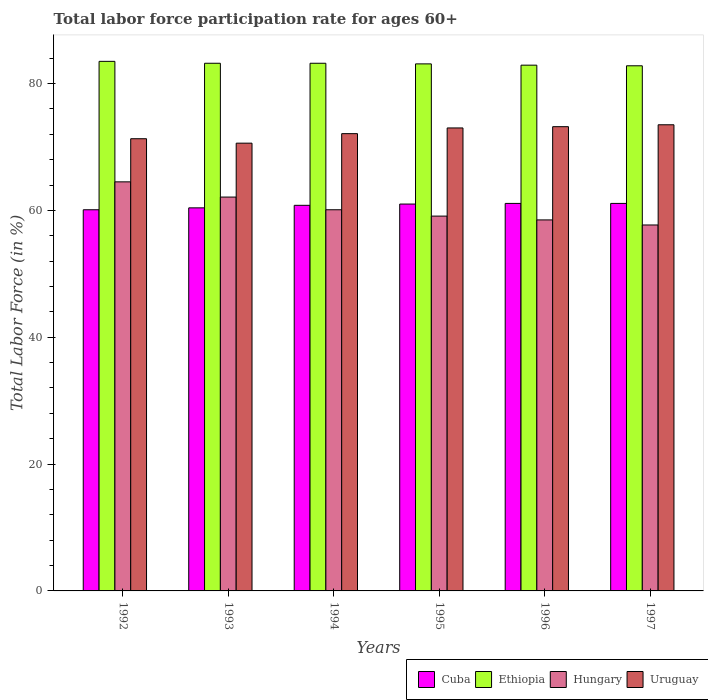How many different coloured bars are there?
Offer a very short reply. 4. How many groups of bars are there?
Your response must be concise. 6. Are the number of bars on each tick of the X-axis equal?
Provide a short and direct response. Yes. How many bars are there on the 4th tick from the left?
Offer a very short reply. 4. How many bars are there on the 5th tick from the right?
Keep it short and to the point. 4. What is the label of the 1st group of bars from the left?
Your answer should be very brief. 1992. In how many cases, is the number of bars for a given year not equal to the number of legend labels?
Your answer should be compact. 0. What is the labor force participation rate in Hungary in 1992?
Provide a succinct answer. 64.5. Across all years, what is the maximum labor force participation rate in Ethiopia?
Keep it short and to the point. 83.5. Across all years, what is the minimum labor force participation rate in Cuba?
Offer a very short reply. 60.1. In which year was the labor force participation rate in Uruguay maximum?
Offer a very short reply. 1997. In which year was the labor force participation rate in Cuba minimum?
Your response must be concise. 1992. What is the total labor force participation rate in Hungary in the graph?
Offer a terse response. 362. What is the difference between the labor force participation rate in Uruguay in 1996 and that in 1997?
Your answer should be very brief. -0.3. What is the difference between the labor force participation rate in Ethiopia in 1997 and the labor force participation rate in Cuba in 1994?
Provide a succinct answer. 22. What is the average labor force participation rate in Ethiopia per year?
Give a very brief answer. 83.12. In the year 1994, what is the difference between the labor force participation rate in Uruguay and labor force participation rate in Ethiopia?
Give a very brief answer. -11.1. What is the ratio of the labor force participation rate in Ethiopia in 1992 to that in 1995?
Your answer should be compact. 1. Is the labor force participation rate in Ethiopia in 1994 less than that in 1997?
Provide a succinct answer. No. Is the difference between the labor force participation rate in Uruguay in 1992 and 1993 greater than the difference between the labor force participation rate in Ethiopia in 1992 and 1993?
Offer a very short reply. Yes. What is the difference between the highest and the lowest labor force participation rate in Cuba?
Offer a very short reply. 1. In how many years, is the labor force participation rate in Hungary greater than the average labor force participation rate in Hungary taken over all years?
Offer a very short reply. 2. Is the sum of the labor force participation rate in Ethiopia in 1994 and 1997 greater than the maximum labor force participation rate in Hungary across all years?
Keep it short and to the point. Yes. Is it the case that in every year, the sum of the labor force participation rate in Cuba and labor force participation rate in Hungary is greater than the sum of labor force participation rate in Uruguay and labor force participation rate in Ethiopia?
Give a very brief answer. No. What does the 1st bar from the left in 1993 represents?
Ensure brevity in your answer.  Cuba. What does the 2nd bar from the right in 1995 represents?
Keep it short and to the point. Hungary. Is it the case that in every year, the sum of the labor force participation rate in Hungary and labor force participation rate in Ethiopia is greater than the labor force participation rate in Uruguay?
Offer a very short reply. Yes. How many bars are there?
Provide a succinct answer. 24. Are all the bars in the graph horizontal?
Provide a succinct answer. No. Does the graph contain any zero values?
Provide a short and direct response. No. Does the graph contain grids?
Make the answer very short. No. What is the title of the graph?
Your answer should be compact. Total labor force participation rate for ages 60+. What is the label or title of the X-axis?
Your answer should be compact. Years. What is the label or title of the Y-axis?
Give a very brief answer. Total Labor Force (in %). What is the Total Labor Force (in %) of Cuba in 1992?
Give a very brief answer. 60.1. What is the Total Labor Force (in %) of Ethiopia in 1992?
Offer a very short reply. 83.5. What is the Total Labor Force (in %) of Hungary in 1992?
Ensure brevity in your answer.  64.5. What is the Total Labor Force (in %) of Uruguay in 1992?
Offer a very short reply. 71.3. What is the Total Labor Force (in %) in Cuba in 1993?
Your answer should be compact. 60.4. What is the Total Labor Force (in %) in Ethiopia in 1993?
Your answer should be compact. 83.2. What is the Total Labor Force (in %) of Hungary in 1993?
Your answer should be very brief. 62.1. What is the Total Labor Force (in %) in Uruguay in 1993?
Your response must be concise. 70.6. What is the Total Labor Force (in %) in Cuba in 1994?
Your answer should be compact. 60.8. What is the Total Labor Force (in %) of Ethiopia in 1994?
Keep it short and to the point. 83.2. What is the Total Labor Force (in %) in Hungary in 1994?
Keep it short and to the point. 60.1. What is the Total Labor Force (in %) in Uruguay in 1994?
Make the answer very short. 72.1. What is the Total Labor Force (in %) in Ethiopia in 1995?
Provide a short and direct response. 83.1. What is the Total Labor Force (in %) of Hungary in 1995?
Your answer should be compact. 59.1. What is the Total Labor Force (in %) of Cuba in 1996?
Provide a short and direct response. 61.1. What is the Total Labor Force (in %) of Ethiopia in 1996?
Offer a terse response. 82.9. What is the Total Labor Force (in %) of Hungary in 1996?
Provide a succinct answer. 58.5. What is the Total Labor Force (in %) of Uruguay in 1996?
Offer a very short reply. 73.2. What is the Total Labor Force (in %) of Cuba in 1997?
Give a very brief answer. 61.1. What is the Total Labor Force (in %) of Ethiopia in 1997?
Give a very brief answer. 82.8. What is the Total Labor Force (in %) of Hungary in 1997?
Offer a very short reply. 57.7. What is the Total Labor Force (in %) in Uruguay in 1997?
Your answer should be compact. 73.5. Across all years, what is the maximum Total Labor Force (in %) of Cuba?
Your answer should be compact. 61.1. Across all years, what is the maximum Total Labor Force (in %) in Ethiopia?
Your response must be concise. 83.5. Across all years, what is the maximum Total Labor Force (in %) in Hungary?
Make the answer very short. 64.5. Across all years, what is the maximum Total Labor Force (in %) in Uruguay?
Provide a short and direct response. 73.5. Across all years, what is the minimum Total Labor Force (in %) in Cuba?
Provide a succinct answer. 60.1. Across all years, what is the minimum Total Labor Force (in %) of Ethiopia?
Offer a terse response. 82.8. Across all years, what is the minimum Total Labor Force (in %) in Hungary?
Provide a succinct answer. 57.7. Across all years, what is the minimum Total Labor Force (in %) in Uruguay?
Offer a very short reply. 70.6. What is the total Total Labor Force (in %) in Cuba in the graph?
Ensure brevity in your answer.  364.5. What is the total Total Labor Force (in %) of Ethiopia in the graph?
Make the answer very short. 498.7. What is the total Total Labor Force (in %) of Hungary in the graph?
Give a very brief answer. 362. What is the total Total Labor Force (in %) in Uruguay in the graph?
Offer a very short reply. 433.7. What is the difference between the Total Labor Force (in %) in Cuba in 1992 and that in 1994?
Give a very brief answer. -0.7. What is the difference between the Total Labor Force (in %) of Hungary in 1992 and that in 1994?
Give a very brief answer. 4.4. What is the difference between the Total Labor Force (in %) in Uruguay in 1992 and that in 1994?
Your answer should be compact. -0.8. What is the difference between the Total Labor Force (in %) in Hungary in 1992 and that in 1995?
Ensure brevity in your answer.  5.4. What is the difference between the Total Labor Force (in %) of Ethiopia in 1992 and that in 1996?
Give a very brief answer. 0.6. What is the difference between the Total Labor Force (in %) of Hungary in 1992 and that in 1997?
Provide a short and direct response. 6.8. What is the difference between the Total Labor Force (in %) in Uruguay in 1992 and that in 1997?
Give a very brief answer. -2.2. What is the difference between the Total Labor Force (in %) in Cuba in 1993 and that in 1994?
Keep it short and to the point. -0.4. What is the difference between the Total Labor Force (in %) of Uruguay in 1993 and that in 1994?
Your answer should be very brief. -1.5. What is the difference between the Total Labor Force (in %) of Cuba in 1993 and that in 1996?
Give a very brief answer. -0.7. What is the difference between the Total Labor Force (in %) of Ethiopia in 1993 and that in 1996?
Ensure brevity in your answer.  0.3. What is the difference between the Total Labor Force (in %) of Ethiopia in 1993 and that in 1997?
Give a very brief answer. 0.4. What is the difference between the Total Labor Force (in %) of Hungary in 1993 and that in 1997?
Offer a terse response. 4.4. What is the difference between the Total Labor Force (in %) in Uruguay in 1993 and that in 1997?
Give a very brief answer. -2.9. What is the difference between the Total Labor Force (in %) in Hungary in 1994 and that in 1995?
Make the answer very short. 1. What is the difference between the Total Labor Force (in %) of Uruguay in 1994 and that in 1995?
Keep it short and to the point. -0.9. What is the difference between the Total Labor Force (in %) of Cuba in 1994 and that in 1996?
Your response must be concise. -0.3. What is the difference between the Total Labor Force (in %) in Uruguay in 1994 and that in 1996?
Keep it short and to the point. -1.1. What is the difference between the Total Labor Force (in %) of Cuba in 1994 and that in 1997?
Make the answer very short. -0.3. What is the difference between the Total Labor Force (in %) of Ethiopia in 1994 and that in 1997?
Provide a succinct answer. 0.4. What is the difference between the Total Labor Force (in %) in Uruguay in 1994 and that in 1997?
Offer a very short reply. -1.4. What is the difference between the Total Labor Force (in %) in Cuba in 1995 and that in 1996?
Offer a very short reply. -0.1. What is the difference between the Total Labor Force (in %) of Hungary in 1995 and that in 1996?
Give a very brief answer. 0.6. What is the difference between the Total Labor Force (in %) of Cuba in 1995 and that in 1997?
Your answer should be compact. -0.1. What is the difference between the Total Labor Force (in %) of Ethiopia in 1995 and that in 1997?
Offer a very short reply. 0.3. What is the difference between the Total Labor Force (in %) in Uruguay in 1995 and that in 1997?
Offer a very short reply. -0.5. What is the difference between the Total Labor Force (in %) in Ethiopia in 1996 and that in 1997?
Offer a very short reply. 0.1. What is the difference between the Total Labor Force (in %) in Hungary in 1996 and that in 1997?
Offer a terse response. 0.8. What is the difference between the Total Labor Force (in %) in Uruguay in 1996 and that in 1997?
Offer a very short reply. -0.3. What is the difference between the Total Labor Force (in %) of Cuba in 1992 and the Total Labor Force (in %) of Ethiopia in 1993?
Offer a terse response. -23.1. What is the difference between the Total Labor Force (in %) of Cuba in 1992 and the Total Labor Force (in %) of Hungary in 1993?
Offer a very short reply. -2. What is the difference between the Total Labor Force (in %) of Ethiopia in 1992 and the Total Labor Force (in %) of Hungary in 1993?
Provide a short and direct response. 21.4. What is the difference between the Total Labor Force (in %) of Hungary in 1992 and the Total Labor Force (in %) of Uruguay in 1993?
Give a very brief answer. -6.1. What is the difference between the Total Labor Force (in %) in Cuba in 1992 and the Total Labor Force (in %) in Ethiopia in 1994?
Make the answer very short. -23.1. What is the difference between the Total Labor Force (in %) in Ethiopia in 1992 and the Total Labor Force (in %) in Hungary in 1994?
Offer a terse response. 23.4. What is the difference between the Total Labor Force (in %) of Ethiopia in 1992 and the Total Labor Force (in %) of Uruguay in 1994?
Provide a short and direct response. 11.4. What is the difference between the Total Labor Force (in %) in Hungary in 1992 and the Total Labor Force (in %) in Uruguay in 1994?
Offer a very short reply. -7.6. What is the difference between the Total Labor Force (in %) in Cuba in 1992 and the Total Labor Force (in %) in Ethiopia in 1995?
Your answer should be very brief. -23. What is the difference between the Total Labor Force (in %) in Cuba in 1992 and the Total Labor Force (in %) in Hungary in 1995?
Offer a very short reply. 1. What is the difference between the Total Labor Force (in %) of Cuba in 1992 and the Total Labor Force (in %) of Uruguay in 1995?
Your response must be concise. -12.9. What is the difference between the Total Labor Force (in %) of Ethiopia in 1992 and the Total Labor Force (in %) of Hungary in 1995?
Keep it short and to the point. 24.4. What is the difference between the Total Labor Force (in %) in Hungary in 1992 and the Total Labor Force (in %) in Uruguay in 1995?
Give a very brief answer. -8.5. What is the difference between the Total Labor Force (in %) in Cuba in 1992 and the Total Labor Force (in %) in Ethiopia in 1996?
Provide a succinct answer. -22.8. What is the difference between the Total Labor Force (in %) of Cuba in 1992 and the Total Labor Force (in %) of Hungary in 1996?
Your answer should be very brief. 1.6. What is the difference between the Total Labor Force (in %) of Cuba in 1992 and the Total Labor Force (in %) of Uruguay in 1996?
Keep it short and to the point. -13.1. What is the difference between the Total Labor Force (in %) in Ethiopia in 1992 and the Total Labor Force (in %) in Hungary in 1996?
Offer a very short reply. 25. What is the difference between the Total Labor Force (in %) of Ethiopia in 1992 and the Total Labor Force (in %) of Uruguay in 1996?
Give a very brief answer. 10.3. What is the difference between the Total Labor Force (in %) in Cuba in 1992 and the Total Labor Force (in %) in Ethiopia in 1997?
Offer a very short reply. -22.7. What is the difference between the Total Labor Force (in %) of Cuba in 1992 and the Total Labor Force (in %) of Hungary in 1997?
Provide a short and direct response. 2.4. What is the difference between the Total Labor Force (in %) of Cuba in 1992 and the Total Labor Force (in %) of Uruguay in 1997?
Offer a very short reply. -13.4. What is the difference between the Total Labor Force (in %) of Ethiopia in 1992 and the Total Labor Force (in %) of Hungary in 1997?
Your answer should be very brief. 25.8. What is the difference between the Total Labor Force (in %) of Ethiopia in 1992 and the Total Labor Force (in %) of Uruguay in 1997?
Ensure brevity in your answer.  10. What is the difference between the Total Labor Force (in %) in Hungary in 1992 and the Total Labor Force (in %) in Uruguay in 1997?
Your answer should be compact. -9. What is the difference between the Total Labor Force (in %) of Cuba in 1993 and the Total Labor Force (in %) of Ethiopia in 1994?
Offer a very short reply. -22.8. What is the difference between the Total Labor Force (in %) of Cuba in 1993 and the Total Labor Force (in %) of Uruguay in 1994?
Your answer should be compact. -11.7. What is the difference between the Total Labor Force (in %) of Ethiopia in 1993 and the Total Labor Force (in %) of Hungary in 1994?
Offer a terse response. 23.1. What is the difference between the Total Labor Force (in %) in Hungary in 1993 and the Total Labor Force (in %) in Uruguay in 1994?
Your response must be concise. -10. What is the difference between the Total Labor Force (in %) in Cuba in 1993 and the Total Labor Force (in %) in Ethiopia in 1995?
Offer a very short reply. -22.7. What is the difference between the Total Labor Force (in %) of Ethiopia in 1993 and the Total Labor Force (in %) of Hungary in 1995?
Your answer should be compact. 24.1. What is the difference between the Total Labor Force (in %) of Hungary in 1993 and the Total Labor Force (in %) of Uruguay in 1995?
Your answer should be very brief. -10.9. What is the difference between the Total Labor Force (in %) in Cuba in 1993 and the Total Labor Force (in %) in Ethiopia in 1996?
Provide a short and direct response. -22.5. What is the difference between the Total Labor Force (in %) of Ethiopia in 1993 and the Total Labor Force (in %) of Hungary in 1996?
Provide a succinct answer. 24.7. What is the difference between the Total Labor Force (in %) in Hungary in 1993 and the Total Labor Force (in %) in Uruguay in 1996?
Offer a terse response. -11.1. What is the difference between the Total Labor Force (in %) of Cuba in 1993 and the Total Labor Force (in %) of Ethiopia in 1997?
Your answer should be compact. -22.4. What is the difference between the Total Labor Force (in %) in Cuba in 1994 and the Total Labor Force (in %) in Ethiopia in 1995?
Your response must be concise. -22.3. What is the difference between the Total Labor Force (in %) in Cuba in 1994 and the Total Labor Force (in %) in Uruguay in 1995?
Give a very brief answer. -12.2. What is the difference between the Total Labor Force (in %) of Ethiopia in 1994 and the Total Labor Force (in %) of Hungary in 1995?
Make the answer very short. 24.1. What is the difference between the Total Labor Force (in %) of Hungary in 1994 and the Total Labor Force (in %) of Uruguay in 1995?
Ensure brevity in your answer.  -12.9. What is the difference between the Total Labor Force (in %) in Cuba in 1994 and the Total Labor Force (in %) in Ethiopia in 1996?
Your answer should be compact. -22.1. What is the difference between the Total Labor Force (in %) in Cuba in 1994 and the Total Labor Force (in %) in Hungary in 1996?
Your response must be concise. 2.3. What is the difference between the Total Labor Force (in %) of Ethiopia in 1994 and the Total Labor Force (in %) of Hungary in 1996?
Make the answer very short. 24.7. What is the difference between the Total Labor Force (in %) of Ethiopia in 1994 and the Total Labor Force (in %) of Uruguay in 1996?
Ensure brevity in your answer.  10. What is the difference between the Total Labor Force (in %) in Hungary in 1994 and the Total Labor Force (in %) in Uruguay in 1996?
Provide a short and direct response. -13.1. What is the difference between the Total Labor Force (in %) of Ethiopia in 1994 and the Total Labor Force (in %) of Hungary in 1997?
Offer a very short reply. 25.5. What is the difference between the Total Labor Force (in %) in Hungary in 1994 and the Total Labor Force (in %) in Uruguay in 1997?
Give a very brief answer. -13.4. What is the difference between the Total Labor Force (in %) of Cuba in 1995 and the Total Labor Force (in %) of Ethiopia in 1996?
Your response must be concise. -21.9. What is the difference between the Total Labor Force (in %) in Cuba in 1995 and the Total Labor Force (in %) in Hungary in 1996?
Your response must be concise. 2.5. What is the difference between the Total Labor Force (in %) in Cuba in 1995 and the Total Labor Force (in %) in Uruguay in 1996?
Make the answer very short. -12.2. What is the difference between the Total Labor Force (in %) of Ethiopia in 1995 and the Total Labor Force (in %) of Hungary in 1996?
Provide a succinct answer. 24.6. What is the difference between the Total Labor Force (in %) of Hungary in 1995 and the Total Labor Force (in %) of Uruguay in 1996?
Offer a very short reply. -14.1. What is the difference between the Total Labor Force (in %) of Cuba in 1995 and the Total Labor Force (in %) of Ethiopia in 1997?
Offer a terse response. -21.8. What is the difference between the Total Labor Force (in %) in Cuba in 1995 and the Total Labor Force (in %) in Uruguay in 1997?
Your answer should be very brief. -12.5. What is the difference between the Total Labor Force (in %) in Ethiopia in 1995 and the Total Labor Force (in %) in Hungary in 1997?
Provide a short and direct response. 25.4. What is the difference between the Total Labor Force (in %) of Hungary in 1995 and the Total Labor Force (in %) of Uruguay in 1997?
Your response must be concise. -14.4. What is the difference between the Total Labor Force (in %) in Cuba in 1996 and the Total Labor Force (in %) in Ethiopia in 1997?
Your answer should be compact. -21.7. What is the difference between the Total Labor Force (in %) in Cuba in 1996 and the Total Labor Force (in %) in Hungary in 1997?
Provide a succinct answer. 3.4. What is the difference between the Total Labor Force (in %) in Ethiopia in 1996 and the Total Labor Force (in %) in Hungary in 1997?
Offer a terse response. 25.2. What is the average Total Labor Force (in %) of Cuba per year?
Your answer should be compact. 60.75. What is the average Total Labor Force (in %) in Ethiopia per year?
Make the answer very short. 83.12. What is the average Total Labor Force (in %) in Hungary per year?
Offer a terse response. 60.33. What is the average Total Labor Force (in %) of Uruguay per year?
Offer a terse response. 72.28. In the year 1992, what is the difference between the Total Labor Force (in %) of Cuba and Total Labor Force (in %) of Ethiopia?
Your response must be concise. -23.4. In the year 1992, what is the difference between the Total Labor Force (in %) of Cuba and Total Labor Force (in %) of Uruguay?
Provide a succinct answer. -11.2. In the year 1992, what is the difference between the Total Labor Force (in %) in Ethiopia and Total Labor Force (in %) in Hungary?
Make the answer very short. 19. In the year 1992, what is the difference between the Total Labor Force (in %) of Hungary and Total Labor Force (in %) of Uruguay?
Make the answer very short. -6.8. In the year 1993, what is the difference between the Total Labor Force (in %) in Cuba and Total Labor Force (in %) in Ethiopia?
Your answer should be very brief. -22.8. In the year 1993, what is the difference between the Total Labor Force (in %) of Cuba and Total Labor Force (in %) of Hungary?
Give a very brief answer. -1.7. In the year 1993, what is the difference between the Total Labor Force (in %) in Cuba and Total Labor Force (in %) in Uruguay?
Provide a succinct answer. -10.2. In the year 1993, what is the difference between the Total Labor Force (in %) of Ethiopia and Total Labor Force (in %) of Hungary?
Your response must be concise. 21.1. In the year 1993, what is the difference between the Total Labor Force (in %) of Hungary and Total Labor Force (in %) of Uruguay?
Offer a terse response. -8.5. In the year 1994, what is the difference between the Total Labor Force (in %) of Cuba and Total Labor Force (in %) of Ethiopia?
Your answer should be very brief. -22.4. In the year 1994, what is the difference between the Total Labor Force (in %) of Ethiopia and Total Labor Force (in %) of Hungary?
Provide a succinct answer. 23.1. In the year 1994, what is the difference between the Total Labor Force (in %) in Hungary and Total Labor Force (in %) in Uruguay?
Provide a succinct answer. -12. In the year 1995, what is the difference between the Total Labor Force (in %) of Cuba and Total Labor Force (in %) of Ethiopia?
Your response must be concise. -22.1. In the year 1995, what is the difference between the Total Labor Force (in %) in Cuba and Total Labor Force (in %) in Uruguay?
Provide a succinct answer. -12. In the year 1995, what is the difference between the Total Labor Force (in %) of Ethiopia and Total Labor Force (in %) of Hungary?
Your response must be concise. 24. In the year 1995, what is the difference between the Total Labor Force (in %) in Hungary and Total Labor Force (in %) in Uruguay?
Your answer should be very brief. -13.9. In the year 1996, what is the difference between the Total Labor Force (in %) of Cuba and Total Labor Force (in %) of Ethiopia?
Give a very brief answer. -21.8. In the year 1996, what is the difference between the Total Labor Force (in %) of Ethiopia and Total Labor Force (in %) of Hungary?
Your answer should be compact. 24.4. In the year 1996, what is the difference between the Total Labor Force (in %) in Ethiopia and Total Labor Force (in %) in Uruguay?
Provide a succinct answer. 9.7. In the year 1996, what is the difference between the Total Labor Force (in %) of Hungary and Total Labor Force (in %) of Uruguay?
Ensure brevity in your answer.  -14.7. In the year 1997, what is the difference between the Total Labor Force (in %) of Cuba and Total Labor Force (in %) of Ethiopia?
Give a very brief answer. -21.7. In the year 1997, what is the difference between the Total Labor Force (in %) in Cuba and Total Labor Force (in %) in Hungary?
Provide a short and direct response. 3.4. In the year 1997, what is the difference between the Total Labor Force (in %) of Ethiopia and Total Labor Force (in %) of Hungary?
Provide a succinct answer. 25.1. In the year 1997, what is the difference between the Total Labor Force (in %) of Hungary and Total Labor Force (in %) of Uruguay?
Give a very brief answer. -15.8. What is the ratio of the Total Labor Force (in %) in Hungary in 1992 to that in 1993?
Offer a terse response. 1.04. What is the ratio of the Total Labor Force (in %) in Uruguay in 1992 to that in 1993?
Provide a succinct answer. 1.01. What is the ratio of the Total Labor Force (in %) in Cuba in 1992 to that in 1994?
Ensure brevity in your answer.  0.99. What is the ratio of the Total Labor Force (in %) of Hungary in 1992 to that in 1994?
Your answer should be compact. 1.07. What is the ratio of the Total Labor Force (in %) of Uruguay in 1992 to that in 1994?
Your response must be concise. 0.99. What is the ratio of the Total Labor Force (in %) in Cuba in 1992 to that in 1995?
Ensure brevity in your answer.  0.99. What is the ratio of the Total Labor Force (in %) of Hungary in 1992 to that in 1995?
Your answer should be compact. 1.09. What is the ratio of the Total Labor Force (in %) in Uruguay in 1992 to that in 1995?
Make the answer very short. 0.98. What is the ratio of the Total Labor Force (in %) of Cuba in 1992 to that in 1996?
Offer a very short reply. 0.98. What is the ratio of the Total Labor Force (in %) of Hungary in 1992 to that in 1996?
Provide a succinct answer. 1.1. What is the ratio of the Total Labor Force (in %) of Cuba in 1992 to that in 1997?
Your answer should be compact. 0.98. What is the ratio of the Total Labor Force (in %) in Ethiopia in 1992 to that in 1997?
Your answer should be compact. 1.01. What is the ratio of the Total Labor Force (in %) in Hungary in 1992 to that in 1997?
Your answer should be compact. 1.12. What is the ratio of the Total Labor Force (in %) in Uruguay in 1992 to that in 1997?
Offer a very short reply. 0.97. What is the ratio of the Total Labor Force (in %) of Cuba in 1993 to that in 1994?
Your answer should be very brief. 0.99. What is the ratio of the Total Labor Force (in %) of Ethiopia in 1993 to that in 1994?
Your response must be concise. 1. What is the ratio of the Total Labor Force (in %) of Uruguay in 1993 to that in 1994?
Provide a succinct answer. 0.98. What is the ratio of the Total Labor Force (in %) in Cuba in 1993 to that in 1995?
Offer a terse response. 0.99. What is the ratio of the Total Labor Force (in %) of Ethiopia in 1993 to that in 1995?
Offer a very short reply. 1. What is the ratio of the Total Labor Force (in %) in Hungary in 1993 to that in 1995?
Your response must be concise. 1.05. What is the ratio of the Total Labor Force (in %) of Uruguay in 1993 to that in 1995?
Keep it short and to the point. 0.97. What is the ratio of the Total Labor Force (in %) of Hungary in 1993 to that in 1996?
Ensure brevity in your answer.  1.06. What is the ratio of the Total Labor Force (in %) in Uruguay in 1993 to that in 1996?
Provide a short and direct response. 0.96. What is the ratio of the Total Labor Force (in %) in Hungary in 1993 to that in 1997?
Your response must be concise. 1.08. What is the ratio of the Total Labor Force (in %) in Uruguay in 1993 to that in 1997?
Give a very brief answer. 0.96. What is the ratio of the Total Labor Force (in %) in Cuba in 1994 to that in 1995?
Your response must be concise. 1. What is the ratio of the Total Labor Force (in %) in Ethiopia in 1994 to that in 1995?
Keep it short and to the point. 1. What is the ratio of the Total Labor Force (in %) in Hungary in 1994 to that in 1995?
Your answer should be very brief. 1.02. What is the ratio of the Total Labor Force (in %) of Hungary in 1994 to that in 1996?
Offer a very short reply. 1.03. What is the ratio of the Total Labor Force (in %) of Uruguay in 1994 to that in 1996?
Offer a terse response. 0.98. What is the ratio of the Total Labor Force (in %) of Ethiopia in 1994 to that in 1997?
Provide a short and direct response. 1. What is the ratio of the Total Labor Force (in %) of Hungary in 1994 to that in 1997?
Give a very brief answer. 1.04. What is the ratio of the Total Labor Force (in %) in Hungary in 1995 to that in 1996?
Your answer should be very brief. 1.01. What is the ratio of the Total Labor Force (in %) in Uruguay in 1995 to that in 1996?
Offer a very short reply. 1. What is the ratio of the Total Labor Force (in %) in Cuba in 1995 to that in 1997?
Keep it short and to the point. 1. What is the ratio of the Total Labor Force (in %) in Ethiopia in 1995 to that in 1997?
Keep it short and to the point. 1. What is the ratio of the Total Labor Force (in %) in Hungary in 1995 to that in 1997?
Ensure brevity in your answer.  1.02. What is the ratio of the Total Labor Force (in %) of Uruguay in 1995 to that in 1997?
Make the answer very short. 0.99. What is the ratio of the Total Labor Force (in %) in Ethiopia in 1996 to that in 1997?
Offer a terse response. 1. What is the ratio of the Total Labor Force (in %) in Hungary in 1996 to that in 1997?
Keep it short and to the point. 1.01. What is the ratio of the Total Labor Force (in %) in Uruguay in 1996 to that in 1997?
Your response must be concise. 1. What is the difference between the highest and the second highest Total Labor Force (in %) in Ethiopia?
Offer a very short reply. 0.3. What is the difference between the highest and the lowest Total Labor Force (in %) in Ethiopia?
Keep it short and to the point. 0.7. What is the difference between the highest and the lowest Total Labor Force (in %) of Hungary?
Give a very brief answer. 6.8. What is the difference between the highest and the lowest Total Labor Force (in %) in Uruguay?
Make the answer very short. 2.9. 